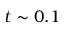<formula> <loc_0><loc_0><loc_500><loc_500>t \sim 0 . 1</formula> 